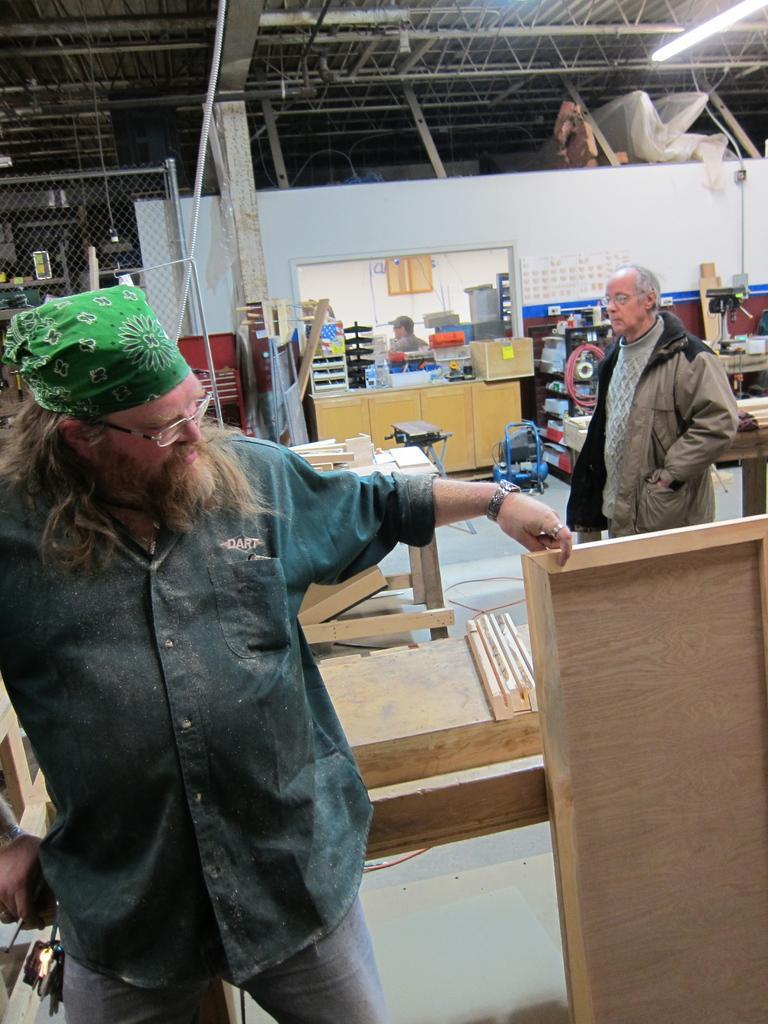Describe this image in one or two sentences. In this picture we can see three men where two are standing and one is sitting and in front of them we can see tables, boxes, racks, net, wooden sticks and in background we can see wall, rods, pipe. 